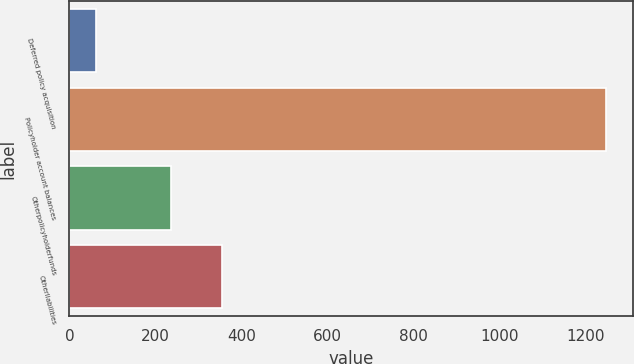Convert chart to OTSL. <chart><loc_0><loc_0><loc_500><loc_500><bar_chart><fcel>Deferred policy acquisition<fcel>Policyholder account balances<fcel>Otherpolicyholderfunds<fcel>Otherliabilities<nl><fcel>61<fcel>1247<fcel>235<fcel>353.6<nl></chart> 